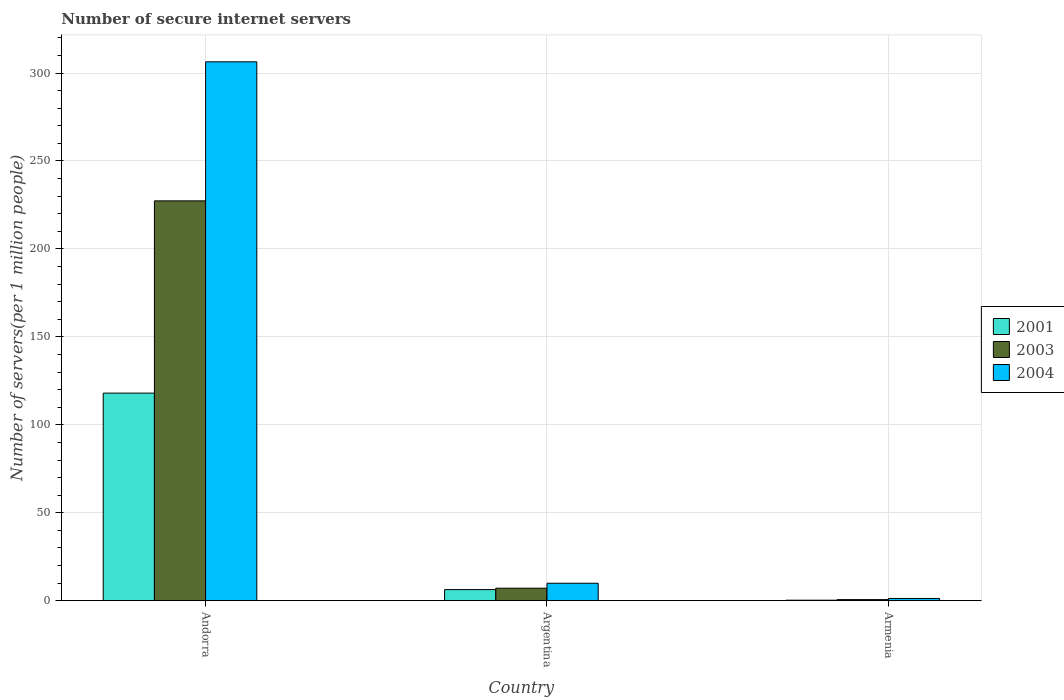Are the number of bars per tick equal to the number of legend labels?
Your response must be concise. Yes. How many bars are there on the 2nd tick from the left?
Provide a succinct answer. 3. What is the label of the 2nd group of bars from the left?
Give a very brief answer. Argentina. What is the number of secure internet servers in 2001 in Armenia?
Offer a very short reply. 0.33. Across all countries, what is the maximum number of secure internet servers in 2004?
Provide a succinct answer. 306.37. Across all countries, what is the minimum number of secure internet servers in 2004?
Keep it short and to the point. 1.32. In which country was the number of secure internet servers in 2004 maximum?
Give a very brief answer. Andorra. In which country was the number of secure internet servers in 2004 minimum?
Keep it short and to the point. Armenia. What is the total number of secure internet servers in 2004 in the graph?
Your answer should be compact. 317.66. What is the difference between the number of secure internet servers in 2003 in Andorra and that in Argentina?
Make the answer very short. 220.17. What is the difference between the number of secure internet servers in 2001 in Argentina and the number of secure internet servers in 2004 in Andorra?
Ensure brevity in your answer.  -300.02. What is the average number of secure internet servers in 2004 per country?
Make the answer very short. 105.89. What is the difference between the number of secure internet servers of/in 2003 and number of secure internet servers of/in 2004 in Armenia?
Your answer should be very brief. -0.66. In how many countries, is the number of secure internet servers in 2001 greater than 200?
Provide a short and direct response. 0. What is the ratio of the number of secure internet servers in 2003 in Andorra to that in Argentina?
Offer a very short reply. 31.78. Is the difference between the number of secure internet servers in 2003 in Argentina and Armenia greater than the difference between the number of secure internet servers in 2004 in Argentina and Armenia?
Offer a terse response. No. What is the difference between the highest and the second highest number of secure internet servers in 2003?
Your answer should be compact. -226.67. What is the difference between the highest and the lowest number of secure internet servers in 2004?
Give a very brief answer. 305.05. In how many countries, is the number of secure internet servers in 2003 greater than the average number of secure internet servers in 2003 taken over all countries?
Ensure brevity in your answer.  1. Is the sum of the number of secure internet servers in 2004 in Argentina and Armenia greater than the maximum number of secure internet servers in 2001 across all countries?
Provide a short and direct response. No. What does the 1st bar from the left in Armenia represents?
Keep it short and to the point. 2001. What does the 1st bar from the right in Armenia represents?
Offer a terse response. 2004. How many bars are there?
Offer a terse response. 9. Where does the legend appear in the graph?
Your answer should be very brief. Center right. What is the title of the graph?
Your answer should be compact. Number of secure internet servers. Does "1987" appear as one of the legend labels in the graph?
Your response must be concise. No. What is the label or title of the Y-axis?
Your answer should be compact. Number of servers(per 1 million people). What is the Number of servers(per 1 million people) in 2001 in Andorra?
Your answer should be very brief. 118.05. What is the Number of servers(per 1 million people) in 2003 in Andorra?
Provide a succinct answer. 227.32. What is the Number of servers(per 1 million people) in 2004 in Andorra?
Keep it short and to the point. 306.37. What is the Number of servers(per 1 million people) of 2001 in Argentina?
Keep it short and to the point. 6.35. What is the Number of servers(per 1 million people) in 2003 in Argentina?
Give a very brief answer. 7.15. What is the Number of servers(per 1 million people) in 2004 in Argentina?
Your response must be concise. 9.97. What is the Number of servers(per 1 million people) of 2001 in Armenia?
Offer a terse response. 0.33. What is the Number of servers(per 1 million people) in 2003 in Armenia?
Offer a terse response. 0.66. What is the Number of servers(per 1 million people) of 2004 in Armenia?
Provide a succinct answer. 1.32. Across all countries, what is the maximum Number of servers(per 1 million people) of 2001?
Give a very brief answer. 118.05. Across all countries, what is the maximum Number of servers(per 1 million people) in 2003?
Ensure brevity in your answer.  227.32. Across all countries, what is the maximum Number of servers(per 1 million people) in 2004?
Ensure brevity in your answer.  306.37. Across all countries, what is the minimum Number of servers(per 1 million people) of 2001?
Make the answer very short. 0.33. Across all countries, what is the minimum Number of servers(per 1 million people) in 2003?
Keep it short and to the point. 0.66. Across all countries, what is the minimum Number of servers(per 1 million people) in 2004?
Provide a short and direct response. 1.32. What is the total Number of servers(per 1 million people) in 2001 in the graph?
Give a very brief answer. 124.72. What is the total Number of servers(per 1 million people) of 2003 in the graph?
Your response must be concise. 235.14. What is the total Number of servers(per 1 million people) in 2004 in the graph?
Provide a succinct answer. 317.66. What is the difference between the Number of servers(per 1 million people) of 2001 in Andorra and that in Argentina?
Provide a short and direct response. 111.69. What is the difference between the Number of servers(per 1 million people) of 2003 in Andorra and that in Argentina?
Keep it short and to the point. 220.17. What is the difference between the Number of servers(per 1 million people) in 2004 in Andorra and that in Argentina?
Your answer should be compact. 296.4. What is the difference between the Number of servers(per 1 million people) in 2001 in Andorra and that in Armenia?
Your answer should be compact. 117.72. What is the difference between the Number of servers(per 1 million people) of 2003 in Andorra and that in Armenia?
Provide a succinct answer. 226.67. What is the difference between the Number of servers(per 1 million people) of 2004 in Andorra and that in Armenia?
Keep it short and to the point. 305.05. What is the difference between the Number of servers(per 1 million people) of 2001 in Argentina and that in Armenia?
Offer a terse response. 6.02. What is the difference between the Number of servers(per 1 million people) in 2003 in Argentina and that in Armenia?
Keep it short and to the point. 6.49. What is the difference between the Number of servers(per 1 million people) in 2004 in Argentina and that in Armenia?
Provide a short and direct response. 8.64. What is the difference between the Number of servers(per 1 million people) of 2001 in Andorra and the Number of servers(per 1 million people) of 2003 in Argentina?
Ensure brevity in your answer.  110.89. What is the difference between the Number of servers(per 1 million people) of 2001 in Andorra and the Number of servers(per 1 million people) of 2004 in Argentina?
Your answer should be compact. 108.08. What is the difference between the Number of servers(per 1 million people) in 2003 in Andorra and the Number of servers(per 1 million people) in 2004 in Argentina?
Offer a terse response. 217.36. What is the difference between the Number of servers(per 1 million people) in 2001 in Andorra and the Number of servers(per 1 million people) in 2003 in Armenia?
Your response must be concise. 117.39. What is the difference between the Number of servers(per 1 million people) in 2001 in Andorra and the Number of servers(per 1 million people) in 2004 in Armenia?
Keep it short and to the point. 116.72. What is the difference between the Number of servers(per 1 million people) in 2003 in Andorra and the Number of servers(per 1 million people) in 2004 in Armenia?
Your answer should be compact. 226. What is the difference between the Number of servers(per 1 million people) in 2001 in Argentina and the Number of servers(per 1 million people) in 2003 in Armenia?
Ensure brevity in your answer.  5.69. What is the difference between the Number of servers(per 1 million people) in 2001 in Argentina and the Number of servers(per 1 million people) in 2004 in Armenia?
Keep it short and to the point. 5.03. What is the difference between the Number of servers(per 1 million people) of 2003 in Argentina and the Number of servers(per 1 million people) of 2004 in Armenia?
Your answer should be very brief. 5.83. What is the average Number of servers(per 1 million people) in 2001 per country?
Provide a short and direct response. 41.57. What is the average Number of servers(per 1 million people) of 2003 per country?
Make the answer very short. 78.38. What is the average Number of servers(per 1 million people) in 2004 per country?
Your answer should be compact. 105.89. What is the difference between the Number of servers(per 1 million people) of 2001 and Number of servers(per 1 million people) of 2003 in Andorra?
Keep it short and to the point. -109.28. What is the difference between the Number of servers(per 1 million people) of 2001 and Number of servers(per 1 million people) of 2004 in Andorra?
Give a very brief answer. -188.32. What is the difference between the Number of servers(per 1 million people) of 2003 and Number of servers(per 1 million people) of 2004 in Andorra?
Ensure brevity in your answer.  -79.04. What is the difference between the Number of servers(per 1 million people) in 2001 and Number of servers(per 1 million people) in 2003 in Argentina?
Provide a short and direct response. -0.8. What is the difference between the Number of servers(per 1 million people) of 2001 and Number of servers(per 1 million people) of 2004 in Argentina?
Your response must be concise. -3.62. What is the difference between the Number of servers(per 1 million people) in 2003 and Number of servers(per 1 million people) in 2004 in Argentina?
Your answer should be compact. -2.81. What is the difference between the Number of servers(per 1 million people) in 2001 and Number of servers(per 1 million people) in 2003 in Armenia?
Offer a very short reply. -0.33. What is the difference between the Number of servers(per 1 million people) of 2001 and Number of servers(per 1 million people) of 2004 in Armenia?
Provide a short and direct response. -1. What is the difference between the Number of servers(per 1 million people) in 2003 and Number of servers(per 1 million people) in 2004 in Armenia?
Keep it short and to the point. -0.66. What is the ratio of the Number of servers(per 1 million people) in 2001 in Andorra to that in Argentina?
Your answer should be very brief. 18.59. What is the ratio of the Number of servers(per 1 million people) of 2003 in Andorra to that in Argentina?
Give a very brief answer. 31.78. What is the ratio of the Number of servers(per 1 million people) in 2004 in Andorra to that in Argentina?
Your answer should be compact. 30.74. What is the ratio of the Number of servers(per 1 million people) in 2001 in Andorra to that in Armenia?
Provide a short and direct response. 361.23. What is the ratio of the Number of servers(per 1 million people) of 2003 in Andorra to that in Armenia?
Your answer should be very brief. 345.13. What is the ratio of the Number of servers(per 1 million people) in 2004 in Andorra to that in Armenia?
Provide a succinct answer. 231.77. What is the ratio of the Number of servers(per 1 million people) of 2001 in Argentina to that in Armenia?
Provide a short and direct response. 19.44. What is the ratio of the Number of servers(per 1 million people) of 2003 in Argentina to that in Armenia?
Give a very brief answer. 10.86. What is the ratio of the Number of servers(per 1 million people) in 2004 in Argentina to that in Armenia?
Offer a terse response. 7.54. What is the difference between the highest and the second highest Number of servers(per 1 million people) in 2001?
Give a very brief answer. 111.69. What is the difference between the highest and the second highest Number of servers(per 1 million people) of 2003?
Your response must be concise. 220.17. What is the difference between the highest and the second highest Number of servers(per 1 million people) in 2004?
Offer a very short reply. 296.4. What is the difference between the highest and the lowest Number of servers(per 1 million people) of 2001?
Give a very brief answer. 117.72. What is the difference between the highest and the lowest Number of servers(per 1 million people) of 2003?
Give a very brief answer. 226.67. What is the difference between the highest and the lowest Number of servers(per 1 million people) of 2004?
Your answer should be very brief. 305.05. 